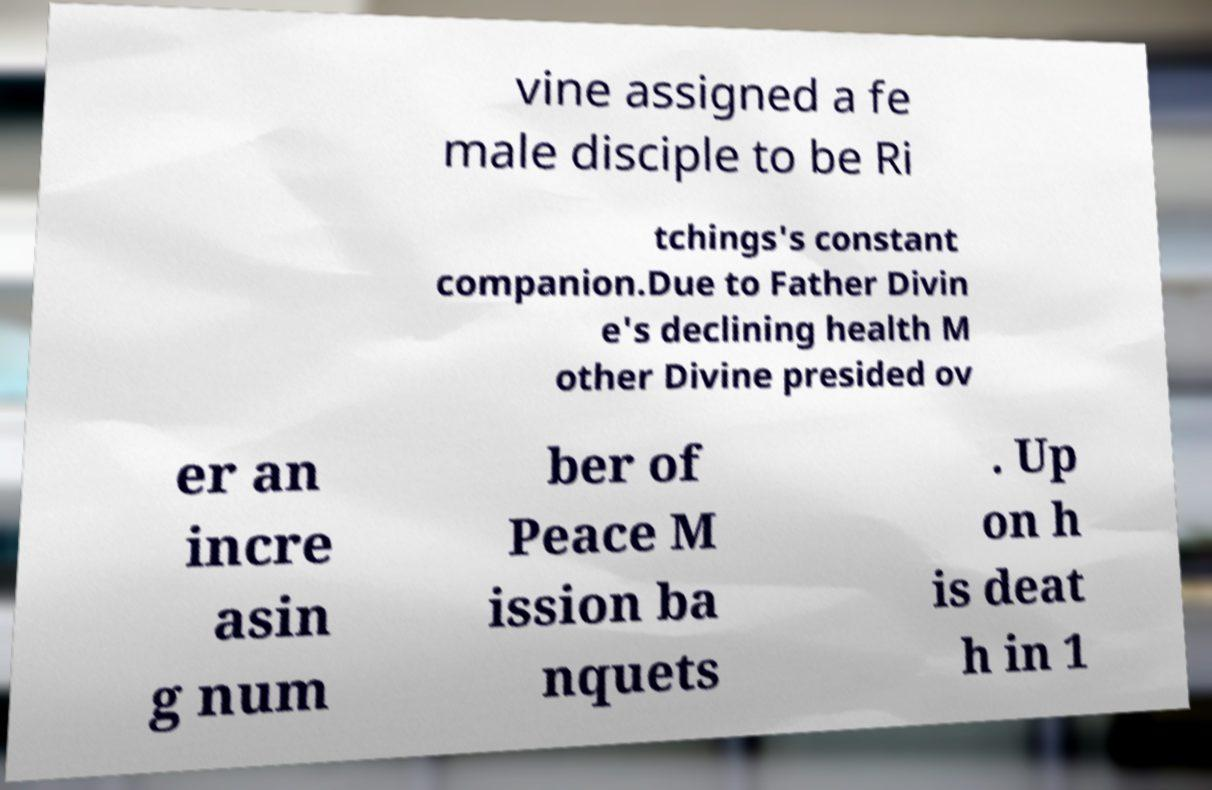I need the written content from this picture converted into text. Can you do that? vine assigned a fe male disciple to be Ri tchings's constant companion.Due to Father Divin e's declining health M other Divine presided ov er an incre asin g num ber of Peace M ission ba nquets . Up on h is deat h in 1 